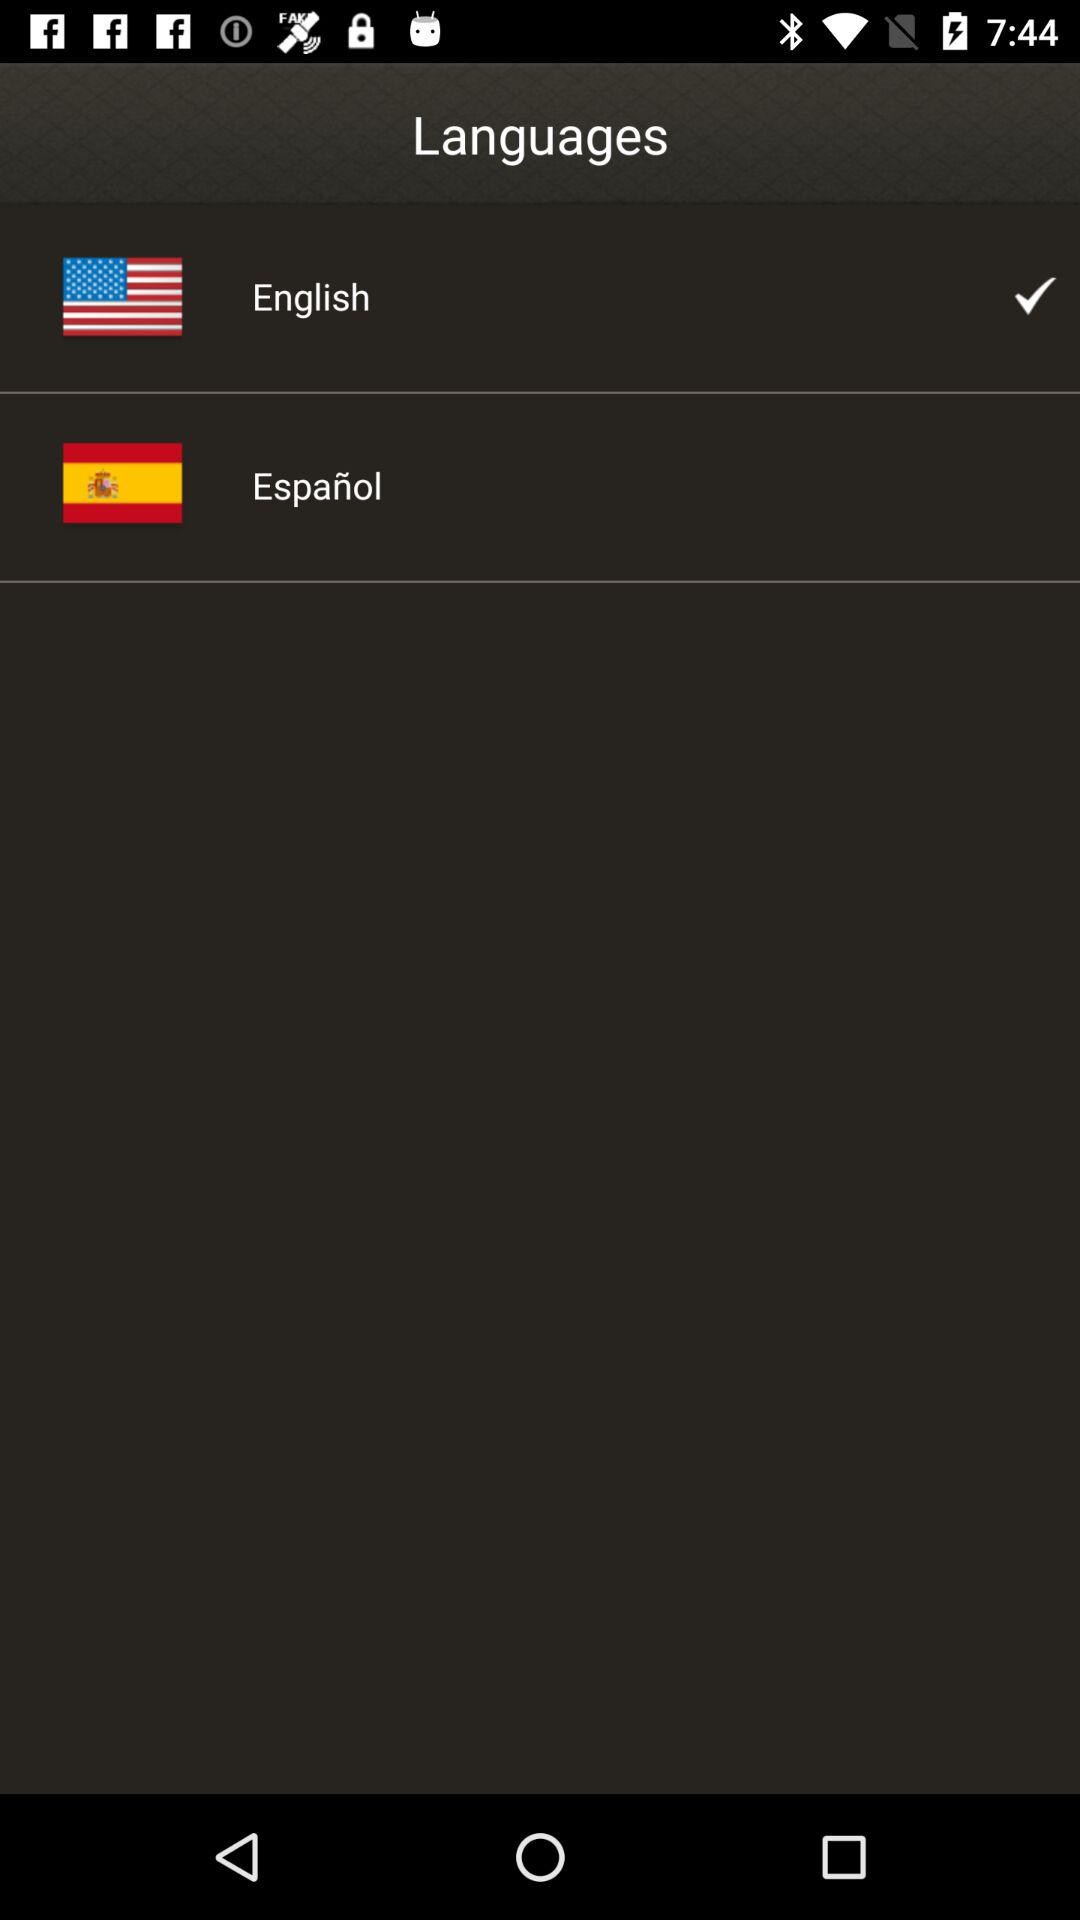Which language is not checked?
Answer the question using a single word or phrase. Español 